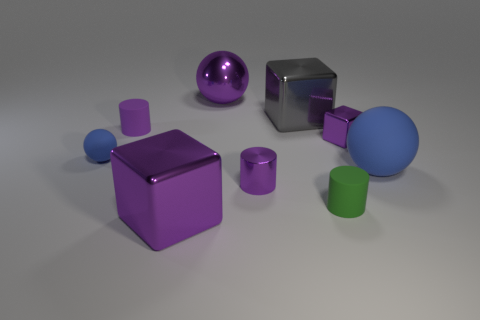Subtract all cylinders. How many objects are left? 6 Add 7 small purple metal objects. How many small purple metal objects exist? 9 Subtract 1 purple blocks. How many objects are left? 8 Subtract all blue matte things. Subtract all small blue matte balls. How many objects are left? 6 Add 5 metallic cylinders. How many metallic cylinders are left? 6 